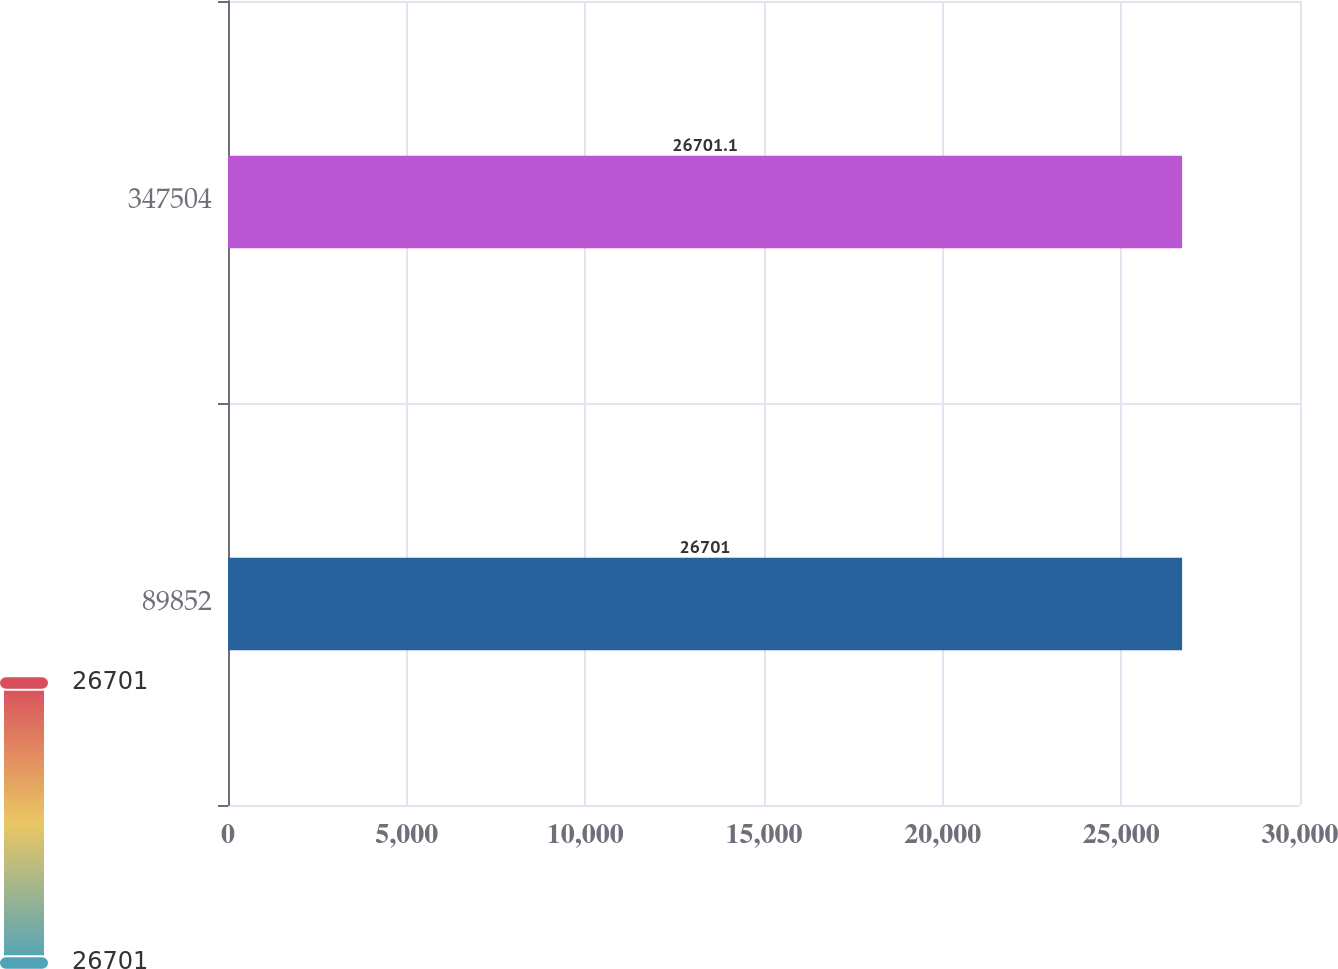Convert chart to OTSL. <chart><loc_0><loc_0><loc_500><loc_500><bar_chart><fcel>89852<fcel>347504<nl><fcel>26701<fcel>26701.1<nl></chart> 